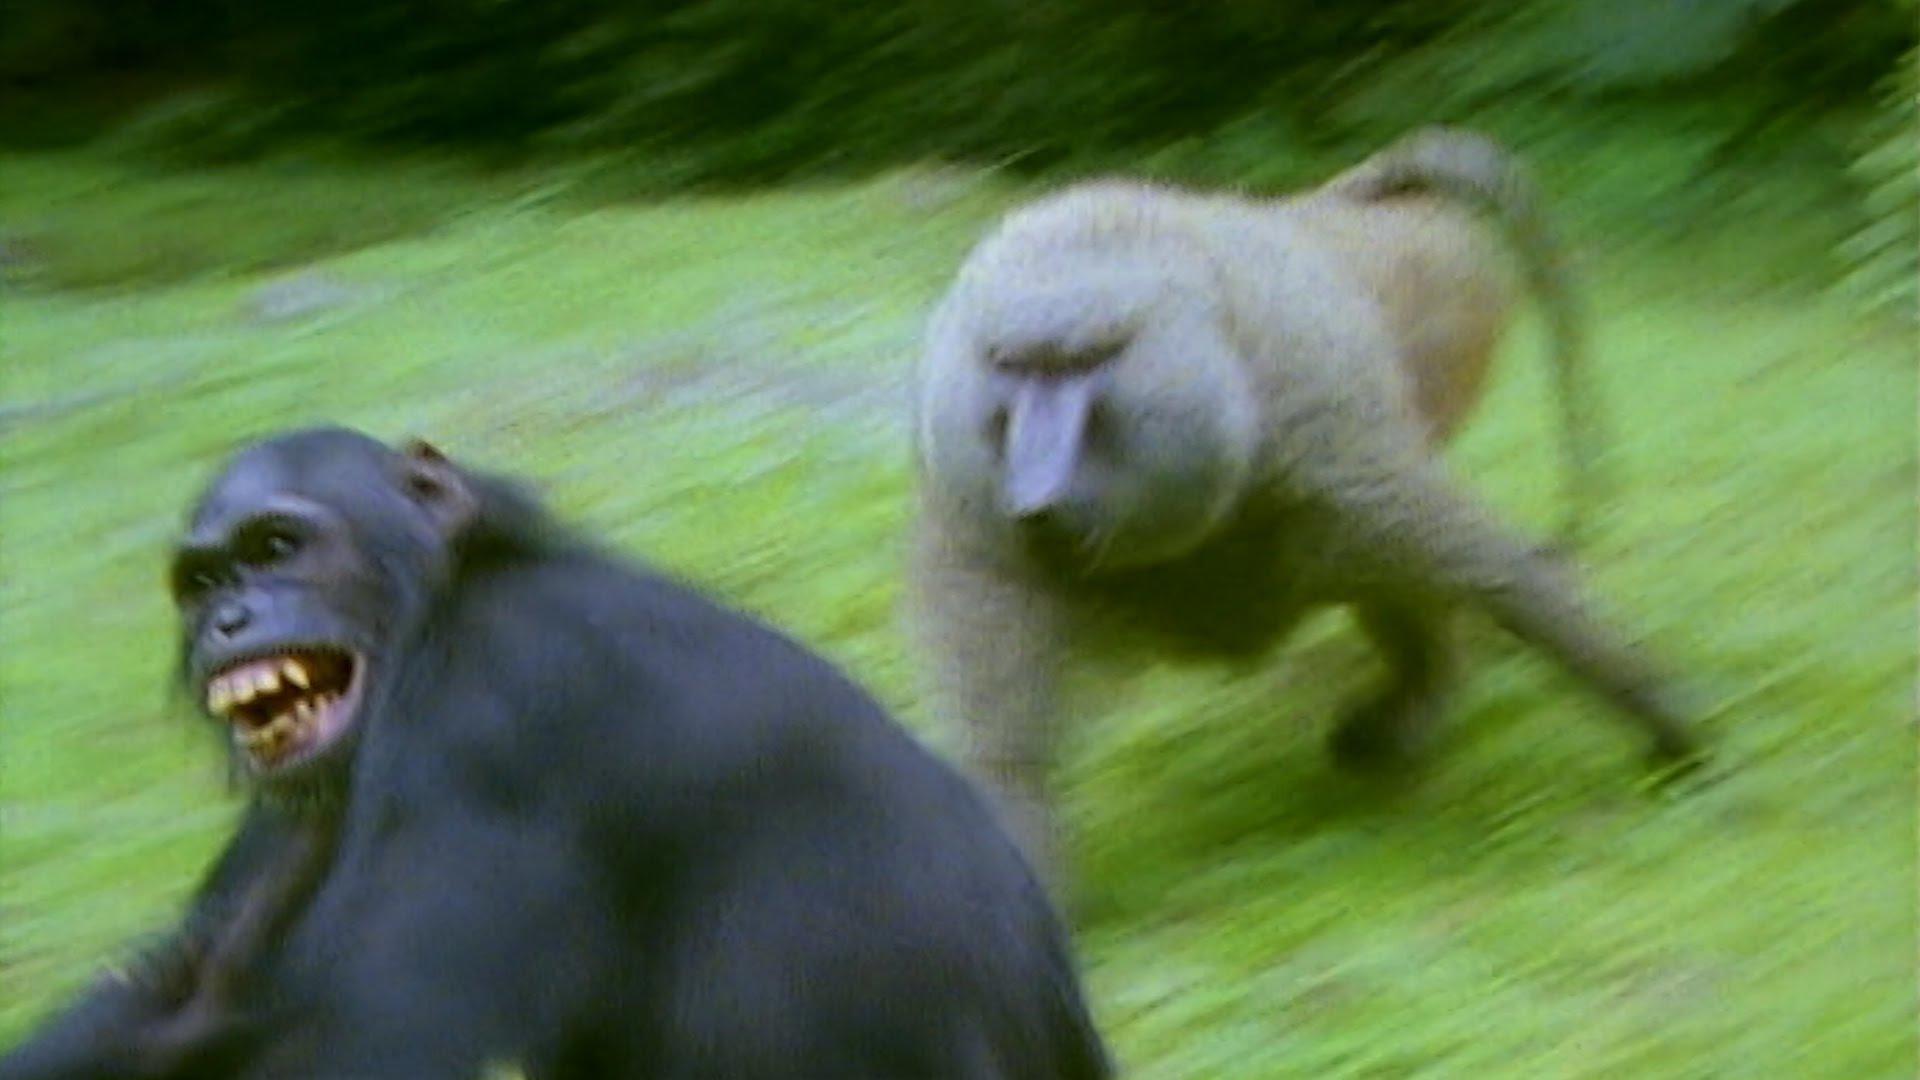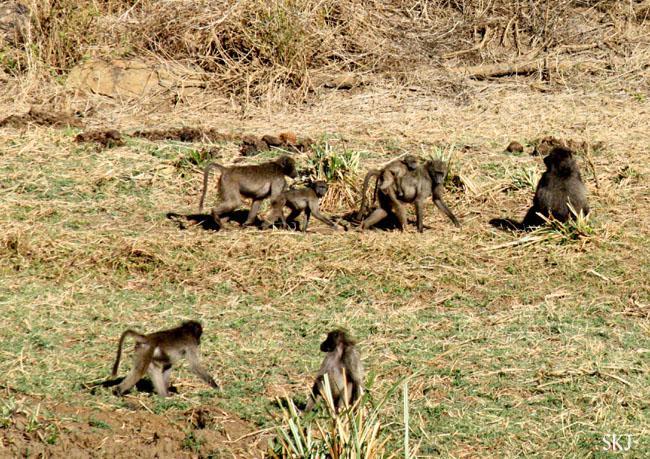The first image is the image on the left, the second image is the image on the right. Examine the images to the left and right. Is the description "There are seven lesser apes in the image to the right." accurate? Answer yes or no. Yes. The first image is the image on the left, the second image is the image on the right. Evaluate the accuracy of this statement regarding the images: "The left image contains no more than four baboons and does not contain any baby baboons.". Is it true? Answer yes or no. Yes. 